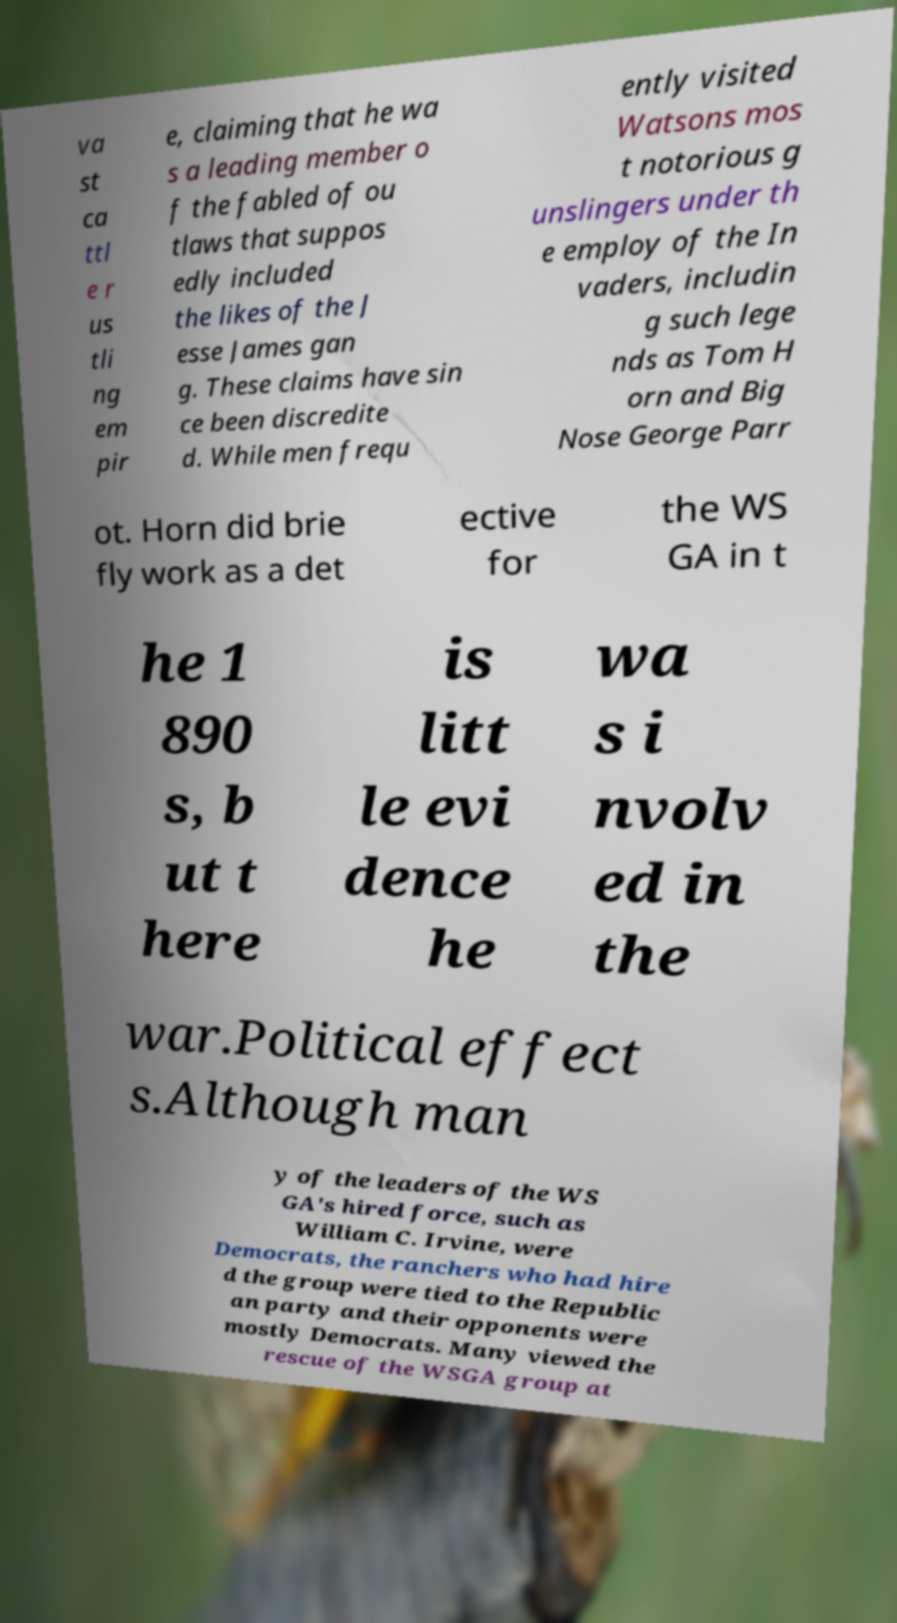I need the written content from this picture converted into text. Can you do that? va st ca ttl e r us tli ng em pir e, claiming that he wa s a leading member o f the fabled of ou tlaws that suppos edly included the likes of the J esse James gan g. These claims have sin ce been discredite d. While men frequ ently visited Watsons mos t notorious g unslingers under th e employ of the In vaders, includin g such lege nds as Tom H orn and Big Nose George Parr ot. Horn did brie fly work as a det ective for the WS GA in t he 1 890 s, b ut t here is litt le evi dence he wa s i nvolv ed in the war.Political effect s.Although man y of the leaders of the WS GA's hired force, such as William C. Irvine, were Democrats, the ranchers who had hire d the group were tied to the Republic an party and their opponents were mostly Democrats. Many viewed the rescue of the WSGA group at 